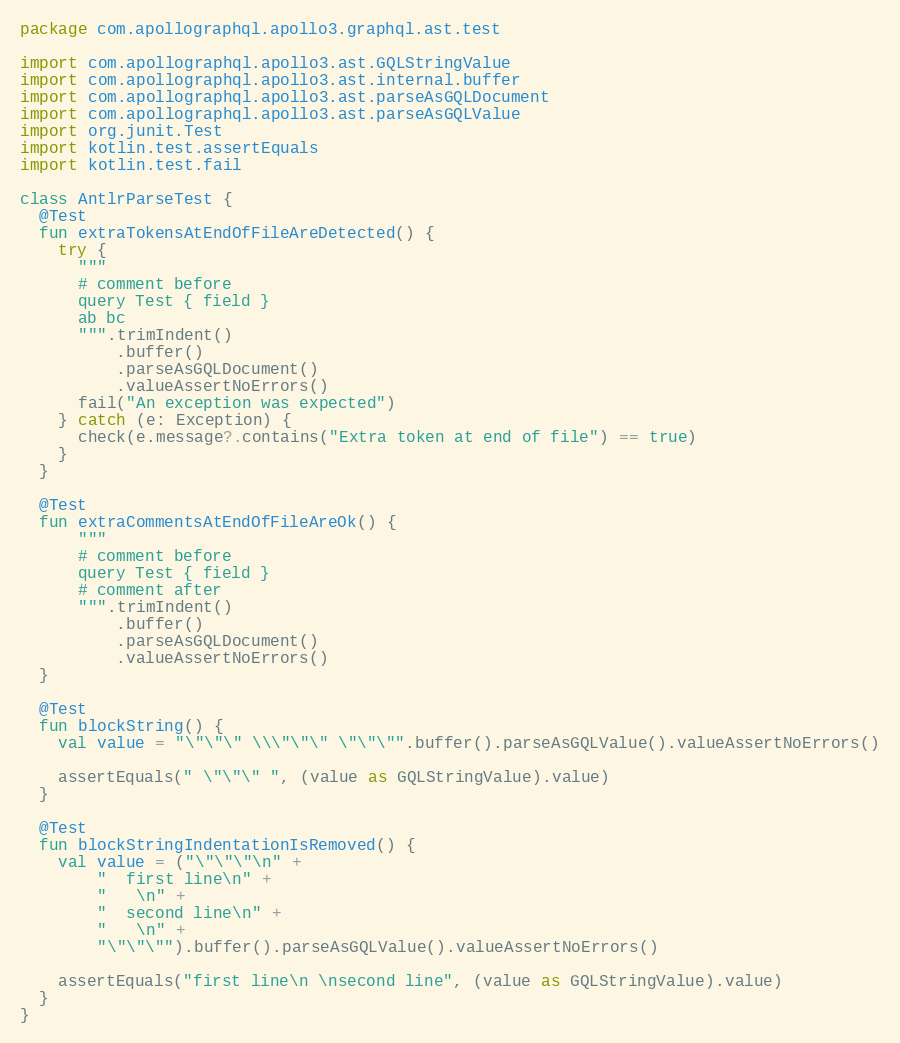<code> <loc_0><loc_0><loc_500><loc_500><_Kotlin_>package com.apollographql.apollo3.graphql.ast.test

import com.apollographql.apollo3.ast.GQLStringValue
import com.apollographql.apollo3.ast.internal.buffer
import com.apollographql.apollo3.ast.parseAsGQLDocument
import com.apollographql.apollo3.ast.parseAsGQLValue
import org.junit.Test
import kotlin.test.assertEquals
import kotlin.test.fail

class AntlrParseTest {
  @Test
  fun extraTokensAtEndOfFileAreDetected() {
    try {
      """
      # comment before
      query Test { field }
      ab bc
      """.trimIndent()
          .buffer()
          .parseAsGQLDocument()
          .valueAssertNoErrors()
      fail("An exception was expected")
    } catch (e: Exception) {
      check(e.message?.contains("Extra token at end of file") == true)
    }
  }

  @Test
  fun extraCommentsAtEndOfFileAreOk() {
      """
      # comment before
      query Test { field }
      # comment after
      """.trimIndent()
          .buffer()
          .parseAsGQLDocument()
          .valueAssertNoErrors()
  }

  @Test
  fun blockString() {
    val value = "\"\"\" \\\"\"\" \"\"\"".buffer().parseAsGQLValue().valueAssertNoErrors()

    assertEquals(" \"\"\" ", (value as GQLStringValue).value)
  }

  @Test
  fun blockStringIndentationIsRemoved() {
    val value = ("\"\"\"\n" +
        "  first line\n" +
        "   \n" +
        "  second line\n" +
        "   \n" +
        "\"\"\"").buffer().parseAsGQLValue().valueAssertNoErrors()

    assertEquals("first line\n \nsecond line", (value as GQLStringValue).value)
  }
}
</code> 